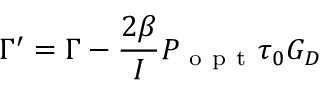<formula> <loc_0><loc_0><loc_500><loc_500>\Gamma ^ { \prime } = \Gamma - \frac { 2 \beta } { I } P _ { o p t } \tau _ { 0 } G _ { D }</formula> 